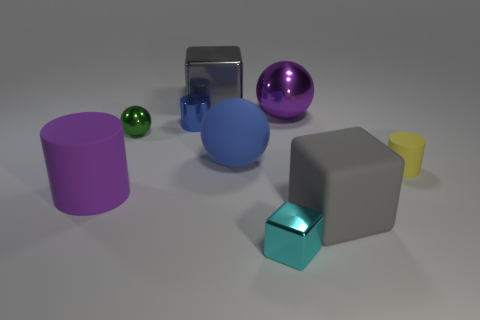What number of brown things are either matte spheres or small metallic blocks?
Provide a short and direct response. 0. Is there a shiny object of the same size as the green ball?
Make the answer very short. Yes. What material is the green ball that is the same size as the cyan cube?
Keep it short and to the point. Metal. Does the shiny thing that is in front of the rubber ball have the same size as the rubber cylinder that is to the right of the big purple cylinder?
Provide a short and direct response. Yes. How many objects are either big blue matte spheres or spheres in front of the green ball?
Ensure brevity in your answer.  1. Is there a large red metal object that has the same shape as the small blue object?
Give a very brief answer. No. There is a purple shiny sphere in front of the gray object behind the purple metallic thing; what size is it?
Ensure brevity in your answer.  Large. Is the big shiny ball the same color as the big rubber sphere?
Offer a very short reply. No. How many rubber objects are either tiny cyan cubes or small objects?
Give a very brief answer. 1. What number of large blue rubber balls are there?
Offer a terse response. 1. 